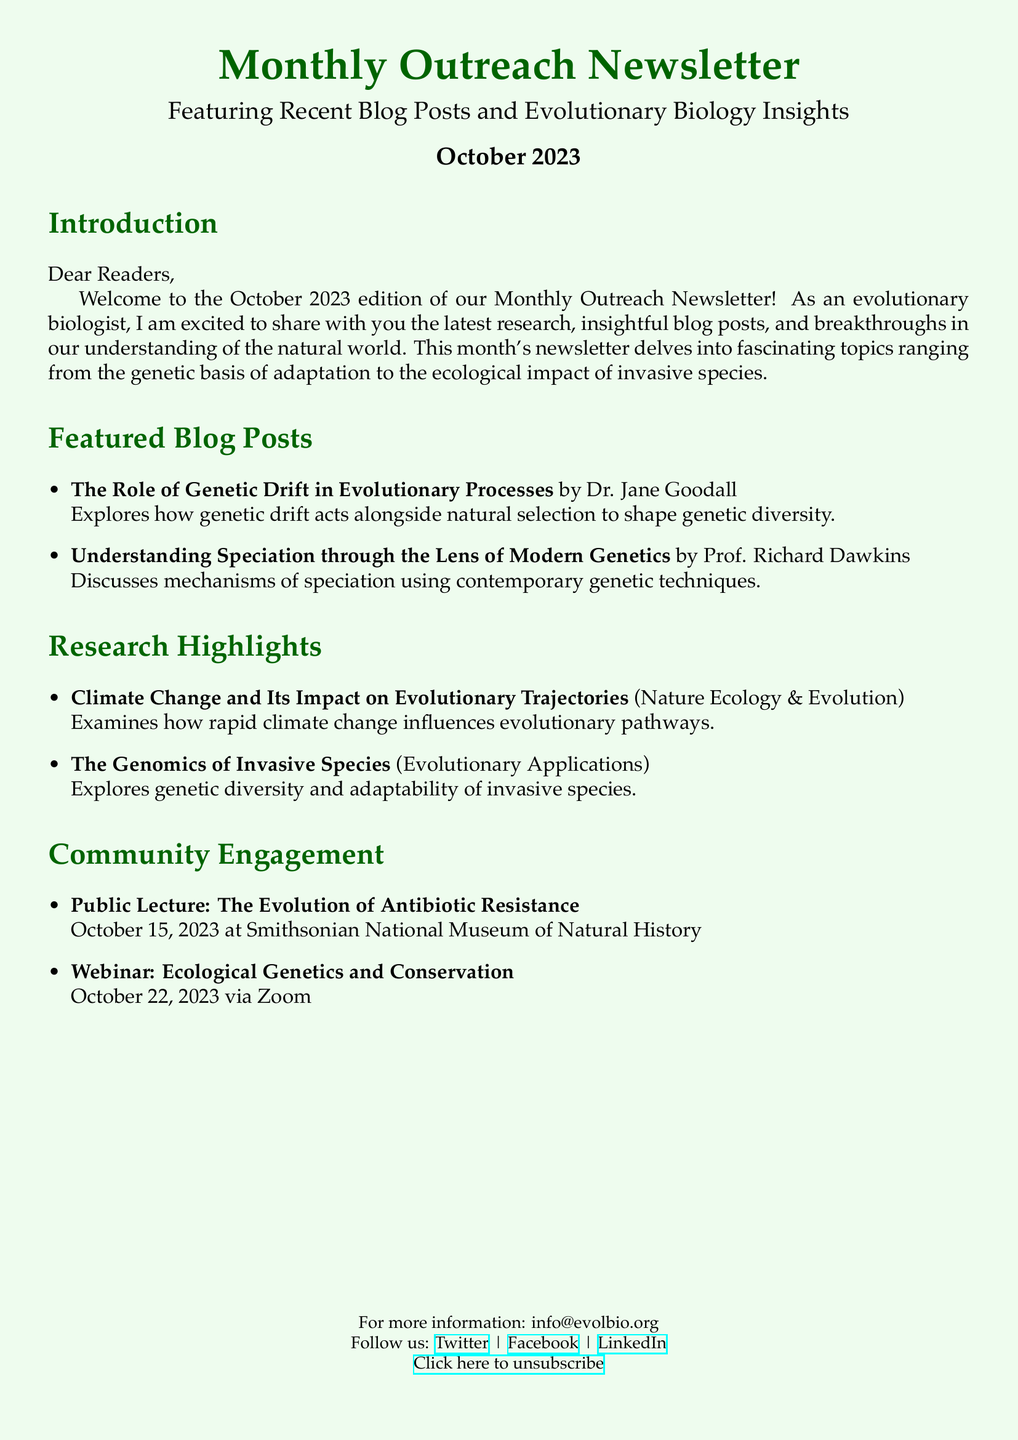What is the title of the newsletter? The title of the newsletter is stated at the top of the document, which is "Monthly Outreach Newsletter."
Answer: Monthly Outreach Newsletter Who wrote the article on genetic drift? The author of the article on genetic drift is mentioned under the title of the blog post, which is Dr. Jane Goodall.
Answer: Dr. Jane Goodall When is the public lecture scheduled? The document lists the date for the public lecture, which is October 15, 2023.
Answer: October 15, 2023 What is the main topic of the featured blog post by Prof. Richard Dawkins? The main topic of the blog post is indicated in the title, addressing mechanisms of speciation.
Answer: Speciation How many featured blog posts are listed in this edition? The document enumerates the blog posts in a bullet-point format, showing there are two featured posts.
Answer: Two What is the topic of the research highlighted from Nature Ecology & Evolution? The document specifies the topic as the impact of climate change on evolutionary trajectories.
Answer: Climate Change and Its Impact on Evolutionary Trajectories What type of engagement event is being held via Zoom? The document mentions a specific type of engagement event, which is a webinar.
Answer: Webinar What is the email address for more information? The email address is provided in the footer section of the document, as info@evolbio.org.
Answer: info@evolbio.org 